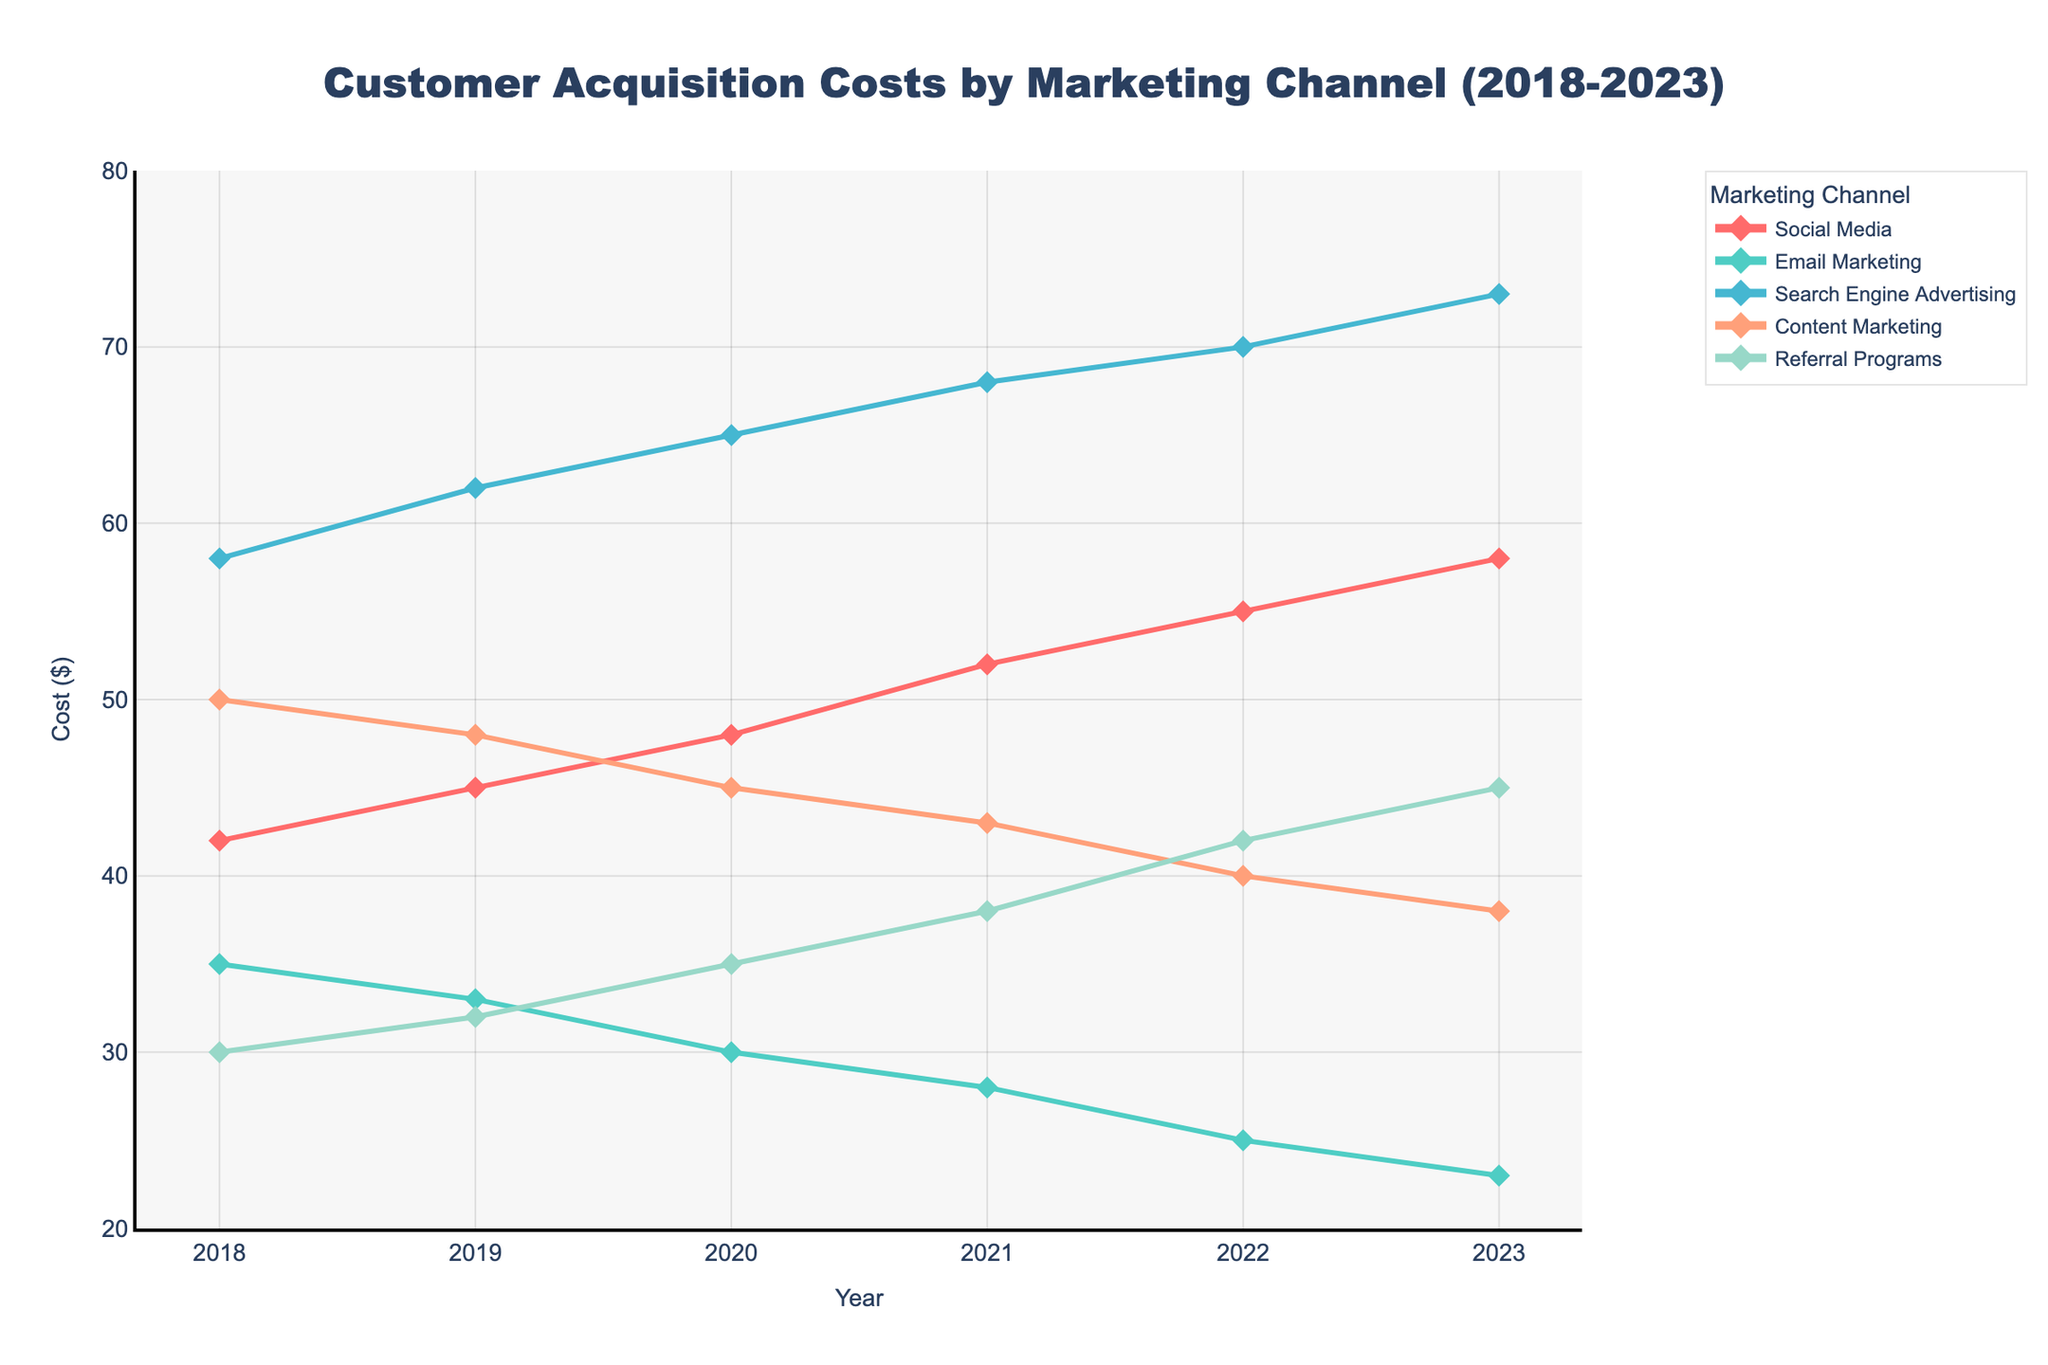What was the Customer Acquisition Cost (CAC) for Social Media in 2021? Locate the line representing Social Media on the chart. In 2021, follow the data point vertically to the y-axis. The CAC for Social Media in 2021 is 52.
Answer: 52 Which marketing channel had the highest CAC in 2023? Examine each line for the year 2023 and identify the highest data point. The line representing Search Engine Advertising has the highest data point in 2023 with a CAC of 73.
Answer: Search Engine Advertising What is the average CAC for Email Marketing from 2018 to 2023? Sum up the Email Marketing CAC values for each year (35 + 33 + 30 + 28 + 25 + 23). Divide the total by the number of years (6). The average CAC is (174 / 6) = 29.
Answer: 29 Compare the CAC trends for Social Media and Content Marketing. Which one increased more sharply? Observe the slope of the lines for Social Media and Content Marketing from 2018 to 2023. The Social Media line has a steeper upward slope than Content Marketing, indicating a sharper increase.
Answer: Social Media In which year did Referral Programs see the highest CAC? Look at the data points for Referral Programs over the years. The highest value is at 45 in 2023.
Answer: 2023 Which marketing channel had decreasing CAC values from 2018 to 2023? Check the trends for each marketing channel. Email Marketing shows a continuous decrease in CAC from 2018 to 2023.
Answer: Email Marketing What was the difference in CAC for Search Engine Advertising between 2018 and 2020? Identify the CAC for Search Engine Advertising in 2018 (58) and 2020 (65). Subtract the 2018 value from the 2020 value (65 - 58). The difference is 7.
Answer: 7 Which year saw the highest CAC for Content Marketing? Examine the Content Marketing line and find the year with the highest data point. The highest CAC for Content Marketing is 50 in 2018.
Answer: 2018 How did the CAC for Referral Programs change from 2022 to 2023? Compare the CAC values for Referral Programs in 2022 (42) and 2023 (45). The difference is 3, indicating an increase.
Answer: Increased by 3 Calculate the total CAC for all channels combined in 2019. Sum the CAC values for all marketing channels in 2019 (45 + 33 + 62 + 48 + 32). The total combined CAC for 2019 is 220.
Answer: 220 